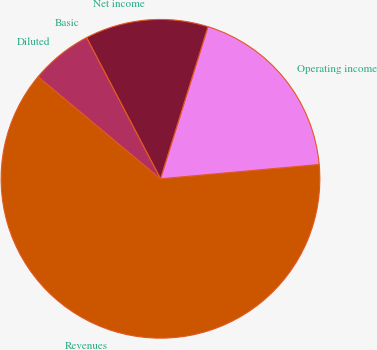<chart> <loc_0><loc_0><loc_500><loc_500><pie_chart><fcel>Revenues<fcel>Operating income<fcel>Net income<fcel>Basic<fcel>Diluted<nl><fcel>62.5%<fcel>18.75%<fcel>12.5%<fcel>0.0%<fcel>6.25%<nl></chart> 